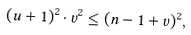Convert formula to latex. <formula><loc_0><loc_0><loc_500><loc_500>( u + 1 ) ^ { 2 } \cdot v ^ { 2 } \leq ( n - 1 + v ) ^ { 2 } ,</formula> 